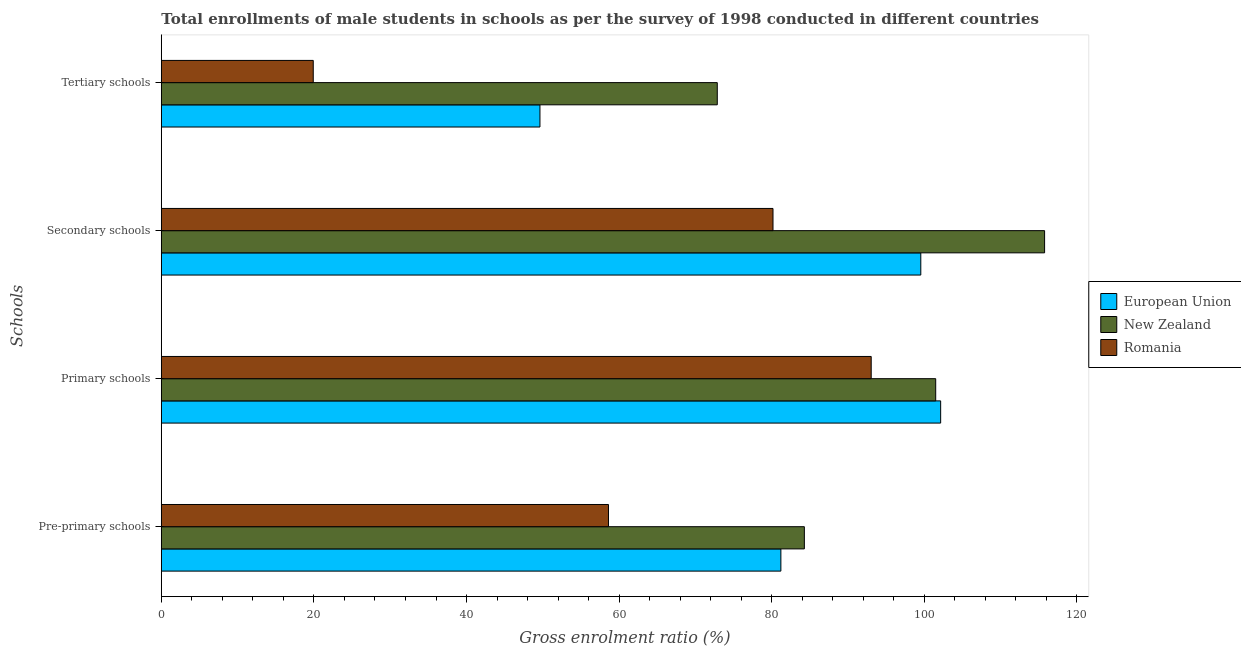How many different coloured bars are there?
Your answer should be very brief. 3. How many groups of bars are there?
Your answer should be compact. 4. How many bars are there on the 3rd tick from the top?
Make the answer very short. 3. What is the label of the 4th group of bars from the top?
Offer a very short reply. Pre-primary schools. What is the gross enrolment ratio(male) in pre-primary schools in European Union?
Your answer should be very brief. 81.2. Across all countries, what is the maximum gross enrolment ratio(male) in secondary schools?
Your answer should be compact. 115.76. Across all countries, what is the minimum gross enrolment ratio(male) in primary schools?
Offer a very short reply. 93.04. In which country was the gross enrolment ratio(male) in pre-primary schools minimum?
Your answer should be compact. Romania. What is the total gross enrolment ratio(male) in pre-primary schools in the graph?
Offer a terse response. 224.08. What is the difference between the gross enrolment ratio(male) in primary schools in New Zealand and that in Romania?
Provide a succinct answer. 8.45. What is the difference between the gross enrolment ratio(male) in primary schools in Romania and the gross enrolment ratio(male) in tertiary schools in European Union?
Provide a short and direct response. 43.41. What is the average gross enrolment ratio(male) in tertiary schools per country?
Your response must be concise. 47.47. What is the difference between the gross enrolment ratio(male) in primary schools and gross enrolment ratio(male) in pre-primary schools in Romania?
Your answer should be very brief. 34.43. What is the ratio of the gross enrolment ratio(male) in pre-primary schools in European Union to that in New Zealand?
Offer a terse response. 0.96. What is the difference between the highest and the second highest gross enrolment ratio(male) in primary schools?
Offer a very short reply. 0.65. What is the difference between the highest and the lowest gross enrolment ratio(male) in secondary schools?
Make the answer very short. 35.59. Is the sum of the gross enrolment ratio(male) in tertiary schools in New Zealand and Romania greater than the maximum gross enrolment ratio(male) in primary schools across all countries?
Your answer should be very brief. No. What does the 1st bar from the top in Primary schools represents?
Your answer should be very brief. Romania. What does the 2nd bar from the bottom in Pre-primary schools represents?
Your answer should be very brief. New Zealand. Are all the bars in the graph horizontal?
Give a very brief answer. Yes. Does the graph contain any zero values?
Your answer should be very brief. No. How many legend labels are there?
Ensure brevity in your answer.  3. What is the title of the graph?
Ensure brevity in your answer.  Total enrollments of male students in schools as per the survey of 1998 conducted in different countries. Does "Nepal" appear as one of the legend labels in the graph?
Offer a terse response. No. What is the label or title of the Y-axis?
Ensure brevity in your answer.  Schools. What is the Gross enrolment ratio (%) in European Union in Pre-primary schools?
Keep it short and to the point. 81.2. What is the Gross enrolment ratio (%) in New Zealand in Pre-primary schools?
Provide a short and direct response. 84.28. What is the Gross enrolment ratio (%) of Romania in Pre-primary schools?
Your answer should be compact. 58.61. What is the Gross enrolment ratio (%) of European Union in Primary schools?
Provide a succinct answer. 102.14. What is the Gross enrolment ratio (%) of New Zealand in Primary schools?
Provide a succinct answer. 101.49. What is the Gross enrolment ratio (%) in Romania in Primary schools?
Provide a short and direct response. 93.04. What is the Gross enrolment ratio (%) in European Union in Secondary schools?
Offer a very short reply. 99.54. What is the Gross enrolment ratio (%) of New Zealand in Secondary schools?
Keep it short and to the point. 115.76. What is the Gross enrolment ratio (%) in Romania in Secondary schools?
Your response must be concise. 80.17. What is the Gross enrolment ratio (%) of European Union in Tertiary schools?
Provide a succinct answer. 49.62. What is the Gross enrolment ratio (%) in New Zealand in Tertiary schools?
Offer a terse response. 72.86. What is the Gross enrolment ratio (%) of Romania in Tertiary schools?
Offer a terse response. 19.91. Across all Schools, what is the maximum Gross enrolment ratio (%) of European Union?
Give a very brief answer. 102.14. Across all Schools, what is the maximum Gross enrolment ratio (%) in New Zealand?
Give a very brief answer. 115.76. Across all Schools, what is the maximum Gross enrolment ratio (%) in Romania?
Your answer should be very brief. 93.04. Across all Schools, what is the minimum Gross enrolment ratio (%) in European Union?
Provide a short and direct response. 49.62. Across all Schools, what is the minimum Gross enrolment ratio (%) in New Zealand?
Give a very brief answer. 72.86. Across all Schools, what is the minimum Gross enrolment ratio (%) in Romania?
Your response must be concise. 19.91. What is the total Gross enrolment ratio (%) of European Union in the graph?
Make the answer very short. 332.5. What is the total Gross enrolment ratio (%) of New Zealand in the graph?
Provide a short and direct response. 374.4. What is the total Gross enrolment ratio (%) of Romania in the graph?
Your answer should be compact. 251.73. What is the difference between the Gross enrolment ratio (%) of European Union in Pre-primary schools and that in Primary schools?
Provide a short and direct response. -20.94. What is the difference between the Gross enrolment ratio (%) in New Zealand in Pre-primary schools and that in Primary schools?
Ensure brevity in your answer.  -17.21. What is the difference between the Gross enrolment ratio (%) in Romania in Pre-primary schools and that in Primary schools?
Offer a very short reply. -34.43. What is the difference between the Gross enrolment ratio (%) in European Union in Pre-primary schools and that in Secondary schools?
Ensure brevity in your answer.  -18.34. What is the difference between the Gross enrolment ratio (%) of New Zealand in Pre-primary schools and that in Secondary schools?
Your response must be concise. -31.49. What is the difference between the Gross enrolment ratio (%) in Romania in Pre-primary schools and that in Secondary schools?
Give a very brief answer. -21.56. What is the difference between the Gross enrolment ratio (%) in European Union in Pre-primary schools and that in Tertiary schools?
Give a very brief answer. 31.58. What is the difference between the Gross enrolment ratio (%) in New Zealand in Pre-primary schools and that in Tertiary schools?
Offer a terse response. 11.41. What is the difference between the Gross enrolment ratio (%) in Romania in Pre-primary schools and that in Tertiary schools?
Provide a succinct answer. 38.69. What is the difference between the Gross enrolment ratio (%) in European Union in Primary schools and that in Secondary schools?
Your answer should be very brief. 2.6. What is the difference between the Gross enrolment ratio (%) in New Zealand in Primary schools and that in Secondary schools?
Ensure brevity in your answer.  -14.27. What is the difference between the Gross enrolment ratio (%) in Romania in Primary schools and that in Secondary schools?
Offer a very short reply. 12.87. What is the difference between the Gross enrolment ratio (%) in European Union in Primary schools and that in Tertiary schools?
Provide a succinct answer. 52.52. What is the difference between the Gross enrolment ratio (%) in New Zealand in Primary schools and that in Tertiary schools?
Keep it short and to the point. 28.63. What is the difference between the Gross enrolment ratio (%) in Romania in Primary schools and that in Tertiary schools?
Offer a terse response. 73.12. What is the difference between the Gross enrolment ratio (%) of European Union in Secondary schools and that in Tertiary schools?
Your answer should be very brief. 49.92. What is the difference between the Gross enrolment ratio (%) of New Zealand in Secondary schools and that in Tertiary schools?
Give a very brief answer. 42.9. What is the difference between the Gross enrolment ratio (%) in Romania in Secondary schools and that in Tertiary schools?
Offer a very short reply. 60.25. What is the difference between the Gross enrolment ratio (%) of European Union in Pre-primary schools and the Gross enrolment ratio (%) of New Zealand in Primary schools?
Keep it short and to the point. -20.29. What is the difference between the Gross enrolment ratio (%) of European Union in Pre-primary schools and the Gross enrolment ratio (%) of Romania in Primary schools?
Your response must be concise. -11.84. What is the difference between the Gross enrolment ratio (%) of New Zealand in Pre-primary schools and the Gross enrolment ratio (%) of Romania in Primary schools?
Offer a very short reply. -8.76. What is the difference between the Gross enrolment ratio (%) of European Union in Pre-primary schools and the Gross enrolment ratio (%) of New Zealand in Secondary schools?
Offer a terse response. -34.56. What is the difference between the Gross enrolment ratio (%) of European Union in Pre-primary schools and the Gross enrolment ratio (%) of Romania in Secondary schools?
Your answer should be very brief. 1.03. What is the difference between the Gross enrolment ratio (%) in New Zealand in Pre-primary schools and the Gross enrolment ratio (%) in Romania in Secondary schools?
Provide a short and direct response. 4.11. What is the difference between the Gross enrolment ratio (%) of European Union in Pre-primary schools and the Gross enrolment ratio (%) of New Zealand in Tertiary schools?
Your response must be concise. 8.34. What is the difference between the Gross enrolment ratio (%) in European Union in Pre-primary schools and the Gross enrolment ratio (%) in Romania in Tertiary schools?
Your response must be concise. 61.29. What is the difference between the Gross enrolment ratio (%) of New Zealand in Pre-primary schools and the Gross enrolment ratio (%) of Romania in Tertiary schools?
Make the answer very short. 64.36. What is the difference between the Gross enrolment ratio (%) of European Union in Primary schools and the Gross enrolment ratio (%) of New Zealand in Secondary schools?
Your answer should be very brief. -13.62. What is the difference between the Gross enrolment ratio (%) of European Union in Primary schools and the Gross enrolment ratio (%) of Romania in Secondary schools?
Offer a very short reply. 21.97. What is the difference between the Gross enrolment ratio (%) of New Zealand in Primary schools and the Gross enrolment ratio (%) of Romania in Secondary schools?
Keep it short and to the point. 21.32. What is the difference between the Gross enrolment ratio (%) of European Union in Primary schools and the Gross enrolment ratio (%) of New Zealand in Tertiary schools?
Your answer should be compact. 29.28. What is the difference between the Gross enrolment ratio (%) of European Union in Primary schools and the Gross enrolment ratio (%) of Romania in Tertiary schools?
Provide a short and direct response. 82.23. What is the difference between the Gross enrolment ratio (%) in New Zealand in Primary schools and the Gross enrolment ratio (%) in Romania in Tertiary schools?
Keep it short and to the point. 81.58. What is the difference between the Gross enrolment ratio (%) of European Union in Secondary schools and the Gross enrolment ratio (%) of New Zealand in Tertiary schools?
Your response must be concise. 26.67. What is the difference between the Gross enrolment ratio (%) of European Union in Secondary schools and the Gross enrolment ratio (%) of Romania in Tertiary schools?
Your response must be concise. 79.63. What is the difference between the Gross enrolment ratio (%) of New Zealand in Secondary schools and the Gross enrolment ratio (%) of Romania in Tertiary schools?
Provide a short and direct response. 95.85. What is the average Gross enrolment ratio (%) of European Union per Schools?
Provide a succinct answer. 83.13. What is the average Gross enrolment ratio (%) of New Zealand per Schools?
Keep it short and to the point. 93.6. What is the average Gross enrolment ratio (%) of Romania per Schools?
Offer a terse response. 62.93. What is the difference between the Gross enrolment ratio (%) of European Union and Gross enrolment ratio (%) of New Zealand in Pre-primary schools?
Your answer should be very brief. -3.08. What is the difference between the Gross enrolment ratio (%) of European Union and Gross enrolment ratio (%) of Romania in Pre-primary schools?
Your answer should be very brief. 22.59. What is the difference between the Gross enrolment ratio (%) of New Zealand and Gross enrolment ratio (%) of Romania in Pre-primary schools?
Ensure brevity in your answer.  25.67. What is the difference between the Gross enrolment ratio (%) of European Union and Gross enrolment ratio (%) of New Zealand in Primary schools?
Your answer should be very brief. 0.65. What is the difference between the Gross enrolment ratio (%) of European Union and Gross enrolment ratio (%) of Romania in Primary schools?
Give a very brief answer. 9.1. What is the difference between the Gross enrolment ratio (%) in New Zealand and Gross enrolment ratio (%) in Romania in Primary schools?
Provide a short and direct response. 8.46. What is the difference between the Gross enrolment ratio (%) of European Union and Gross enrolment ratio (%) of New Zealand in Secondary schools?
Ensure brevity in your answer.  -16.22. What is the difference between the Gross enrolment ratio (%) of European Union and Gross enrolment ratio (%) of Romania in Secondary schools?
Your answer should be compact. 19.37. What is the difference between the Gross enrolment ratio (%) of New Zealand and Gross enrolment ratio (%) of Romania in Secondary schools?
Keep it short and to the point. 35.59. What is the difference between the Gross enrolment ratio (%) of European Union and Gross enrolment ratio (%) of New Zealand in Tertiary schools?
Your answer should be very brief. -23.24. What is the difference between the Gross enrolment ratio (%) of European Union and Gross enrolment ratio (%) of Romania in Tertiary schools?
Make the answer very short. 29.71. What is the difference between the Gross enrolment ratio (%) in New Zealand and Gross enrolment ratio (%) in Romania in Tertiary schools?
Provide a short and direct response. 52.95. What is the ratio of the Gross enrolment ratio (%) in European Union in Pre-primary schools to that in Primary schools?
Provide a succinct answer. 0.8. What is the ratio of the Gross enrolment ratio (%) of New Zealand in Pre-primary schools to that in Primary schools?
Your response must be concise. 0.83. What is the ratio of the Gross enrolment ratio (%) of Romania in Pre-primary schools to that in Primary schools?
Offer a very short reply. 0.63. What is the ratio of the Gross enrolment ratio (%) in European Union in Pre-primary schools to that in Secondary schools?
Your answer should be compact. 0.82. What is the ratio of the Gross enrolment ratio (%) in New Zealand in Pre-primary schools to that in Secondary schools?
Your answer should be compact. 0.73. What is the ratio of the Gross enrolment ratio (%) of Romania in Pre-primary schools to that in Secondary schools?
Offer a very short reply. 0.73. What is the ratio of the Gross enrolment ratio (%) in European Union in Pre-primary schools to that in Tertiary schools?
Your response must be concise. 1.64. What is the ratio of the Gross enrolment ratio (%) of New Zealand in Pre-primary schools to that in Tertiary schools?
Ensure brevity in your answer.  1.16. What is the ratio of the Gross enrolment ratio (%) in Romania in Pre-primary schools to that in Tertiary schools?
Provide a succinct answer. 2.94. What is the ratio of the Gross enrolment ratio (%) in European Union in Primary schools to that in Secondary schools?
Offer a very short reply. 1.03. What is the ratio of the Gross enrolment ratio (%) of New Zealand in Primary schools to that in Secondary schools?
Offer a very short reply. 0.88. What is the ratio of the Gross enrolment ratio (%) of Romania in Primary schools to that in Secondary schools?
Offer a terse response. 1.16. What is the ratio of the Gross enrolment ratio (%) in European Union in Primary schools to that in Tertiary schools?
Offer a very short reply. 2.06. What is the ratio of the Gross enrolment ratio (%) of New Zealand in Primary schools to that in Tertiary schools?
Offer a very short reply. 1.39. What is the ratio of the Gross enrolment ratio (%) in Romania in Primary schools to that in Tertiary schools?
Your answer should be compact. 4.67. What is the ratio of the Gross enrolment ratio (%) of European Union in Secondary schools to that in Tertiary schools?
Offer a very short reply. 2.01. What is the ratio of the Gross enrolment ratio (%) of New Zealand in Secondary schools to that in Tertiary schools?
Ensure brevity in your answer.  1.59. What is the ratio of the Gross enrolment ratio (%) of Romania in Secondary schools to that in Tertiary schools?
Make the answer very short. 4.03. What is the difference between the highest and the second highest Gross enrolment ratio (%) in European Union?
Offer a terse response. 2.6. What is the difference between the highest and the second highest Gross enrolment ratio (%) of New Zealand?
Your answer should be very brief. 14.27. What is the difference between the highest and the second highest Gross enrolment ratio (%) in Romania?
Offer a very short reply. 12.87. What is the difference between the highest and the lowest Gross enrolment ratio (%) of European Union?
Your answer should be compact. 52.52. What is the difference between the highest and the lowest Gross enrolment ratio (%) of New Zealand?
Give a very brief answer. 42.9. What is the difference between the highest and the lowest Gross enrolment ratio (%) in Romania?
Offer a terse response. 73.12. 